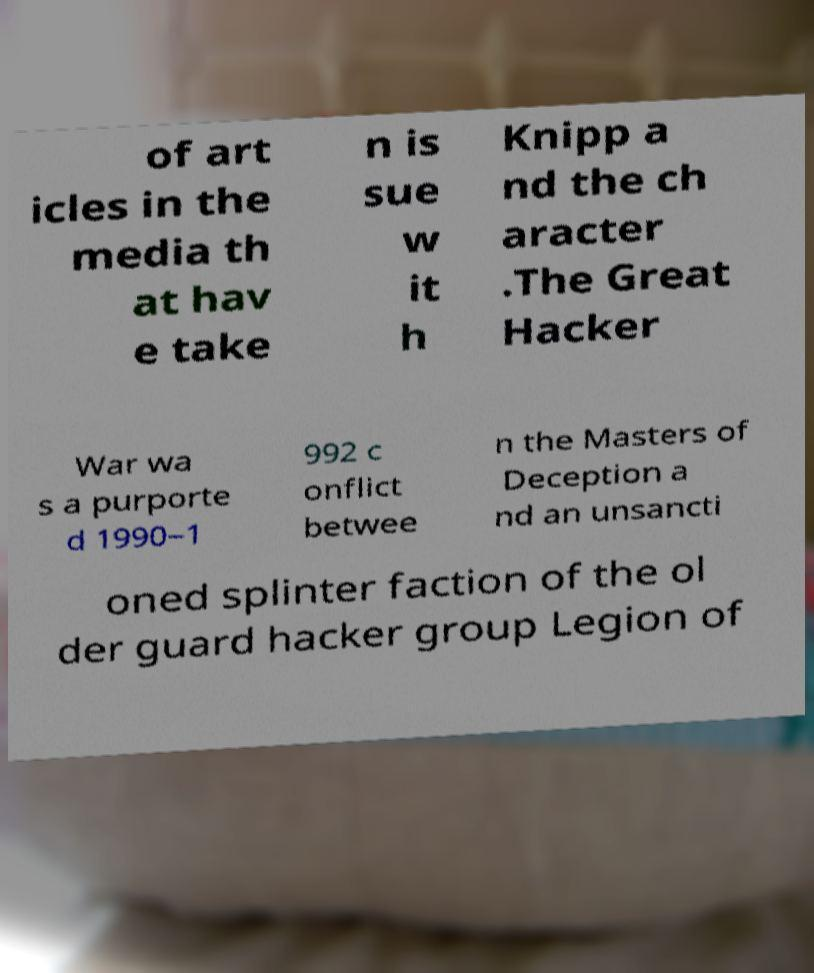Can you read and provide the text displayed in the image?This photo seems to have some interesting text. Can you extract and type it out for me? of art icles in the media th at hav e take n is sue w it h Knipp a nd the ch aracter .The Great Hacker War wa s a purporte d 1990–1 992 c onflict betwee n the Masters of Deception a nd an unsancti oned splinter faction of the ol der guard hacker group Legion of 